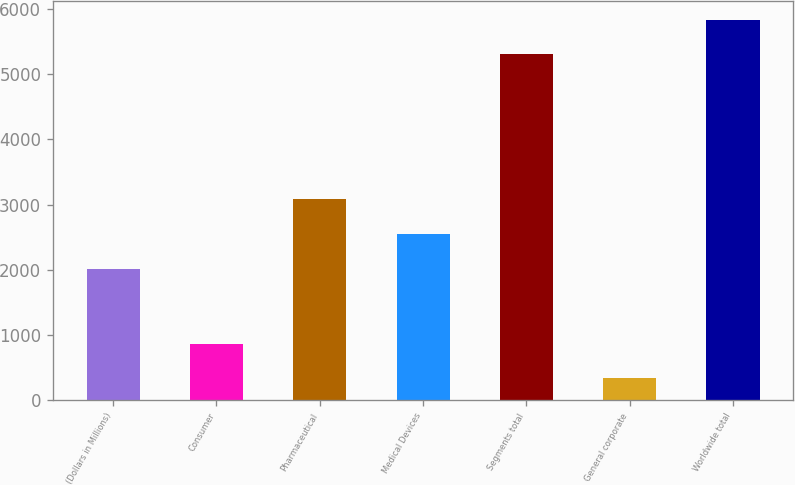<chart> <loc_0><loc_0><loc_500><loc_500><bar_chart><fcel>(Dollars in Millions)<fcel>Consumer<fcel>Pharmaceutical<fcel>Medical Devices<fcel>Segments total<fcel>General corporate<fcel>Worldwide total<nl><fcel>2017<fcel>866.6<fcel>3078.2<fcel>2547.6<fcel>5306<fcel>336<fcel>5836.6<nl></chart> 